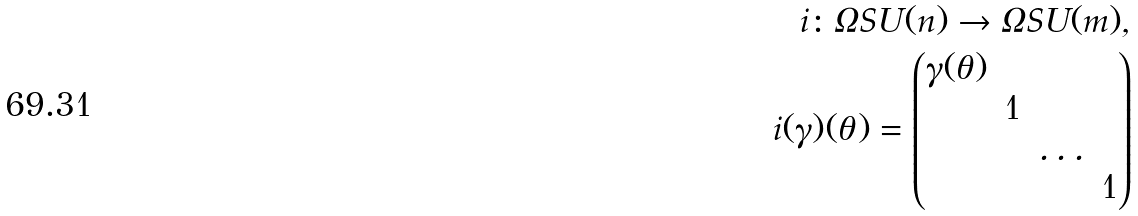Convert formula to latex. <formula><loc_0><loc_0><loc_500><loc_500>i \colon \Omega S U ( n ) \to \Omega S U ( m ) , \\ i ( \gamma ) ( \theta ) = \begin{pmatrix} \gamma ( \theta ) & \\ & 1 \\ & & \dots \\ & & & 1 \\ \end{pmatrix}</formula> 